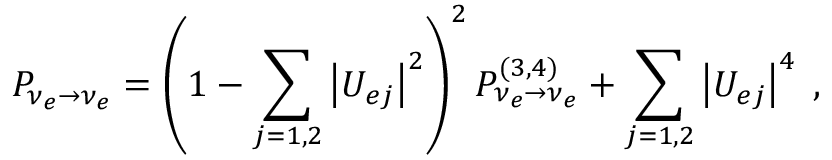<formula> <loc_0><loc_0><loc_500><loc_500>P _ { \nu _ { e } \to \nu _ { e } } = \left ( 1 - \sum _ { j = 1 , 2 } \left | U _ { e j } \right | ^ { 2 } \right ) ^ { 2 } P _ { \nu _ { e } \to \nu _ { e } } ^ { ( 3 , 4 ) } + \sum _ { j = 1 , 2 } \left | U _ { e j } \right | ^ { 4 } \, ,</formula> 